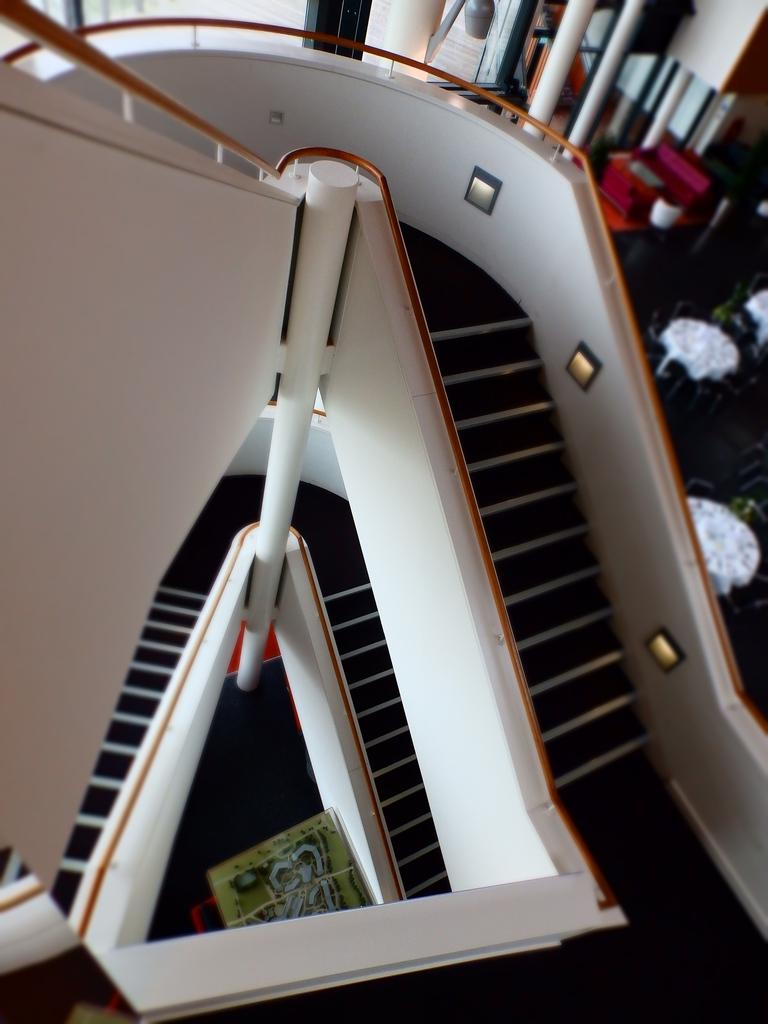What type of structure is present in the image? There are stairs with railing in the image. What can be seen illuminating the area in the image? There are lights in the image. What is the tall, vertical object in the image? There is a pole in the image. What is the flat, rectangular object in the image? There is a board in the image. How many poles are visible in the background of the image? There are multiple poles in the background of the image. What other objects can be seen in the background of the image? There are other objects visible in the background of the image. What type of knot is tied around the pole in the image? There is no knot tied around the pole in the image. What type of wheel is attached to the board in the image? There is no wheel attached to the board in the image. 